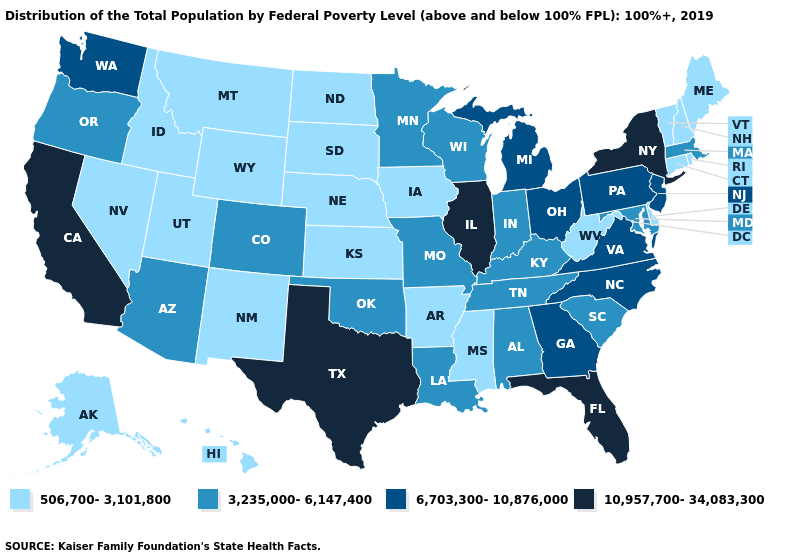Does Hawaii have the lowest value in the West?
Answer briefly. Yes. Name the states that have a value in the range 6,703,300-10,876,000?
Concise answer only. Georgia, Michigan, New Jersey, North Carolina, Ohio, Pennsylvania, Virginia, Washington. What is the highest value in states that border Washington?
Give a very brief answer. 3,235,000-6,147,400. Does Florida have the lowest value in the USA?
Write a very short answer. No. Name the states that have a value in the range 6,703,300-10,876,000?
Concise answer only. Georgia, Michigan, New Jersey, North Carolina, Ohio, Pennsylvania, Virginia, Washington. What is the highest value in states that border Georgia?
Give a very brief answer. 10,957,700-34,083,300. Does Georgia have the highest value in the South?
Concise answer only. No. What is the value of New Hampshire?
Short answer required. 506,700-3,101,800. Among the states that border South Dakota , does Iowa have the lowest value?
Be succinct. Yes. Which states have the lowest value in the MidWest?
Answer briefly. Iowa, Kansas, Nebraska, North Dakota, South Dakota. What is the highest value in states that border Iowa?
Short answer required. 10,957,700-34,083,300. What is the highest value in states that border Utah?
Concise answer only. 3,235,000-6,147,400. What is the value of North Carolina?
Short answer required. 6,703,300-10,876,000. Among the states that border Michigan , does Indiana have the lowest value?
Short answer required. Yes. Name the states that have a value in the range 3,235,000-6,147,400?
Short answer required. Alabama, Arizona, Colorado, Indiana, Kentucky, Louisiana, Maryland, Massachusetts, Minnesota, Missouri, Oklahoma, Oregon, South Carolina, Tennessee, Wisconsin. 